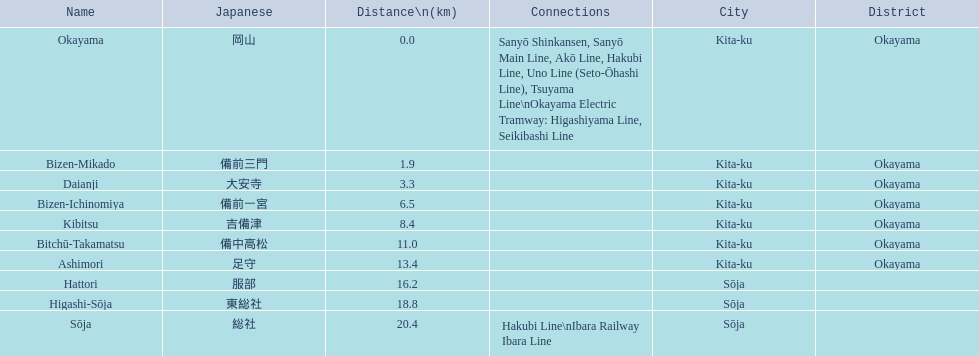What are the members of the kibi line? Okayama, Bizen-Mikado, Daianji, Bizen-Ichinomiya, Kibitsu, Bitchū-Takamatsu, Ashimori, Hattori, Higashi-Sōja, Sōja. Which of them have a distance of more than 1 km? Bizen-Mikado, Daianji, Bizen-Ichinomiya, Kibitsu, Bitchū-Takamatsu, Ashimori, Hattori, Higashi-Sōja, Sōja. Which of them have a distance of less than 2 km? Okayama, Bizen-Mikado. Which has a distance between 1 km and 2 km? Bizen-Mikado. 